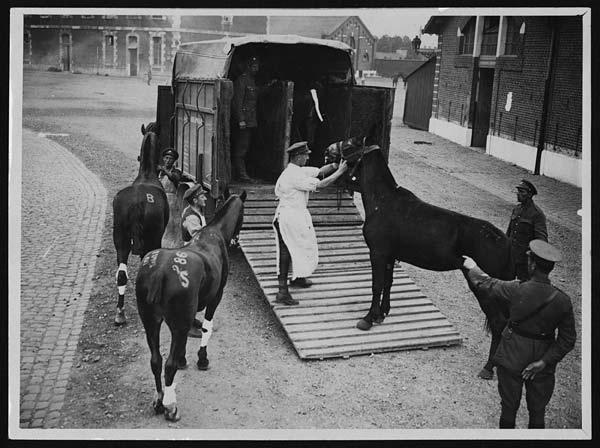How many animals are there?
Give a very brief answer. 3. How many people are visible in the picture?
Give a very brief answer. 5. How many people can you see?
Give a very brief answer. 4. How many horses are there?
Give a very brief answer. 3. 